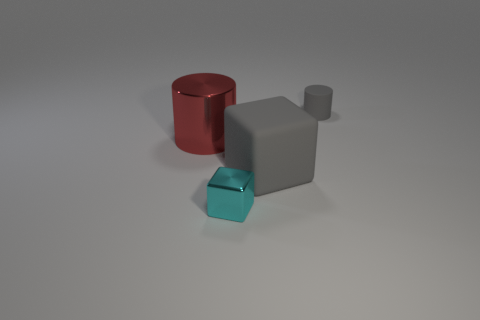Is the material of the small thing that is to the right of the small cyan metal block the same as the big gray cube?
Your answer should be very brief. Yes. How many objects are small cylinders or metallic things in front of the red shiny cylinder?
Keep it short and to the point. 2. What size is the red thing that is the same shape as the tiny gray matte thing?
Keep it short and to the point. Large. There is a large shiny thing; are there any cylinders on the right side of it?
Offer a terse response. Yes. Does the thing that is to the right of the big gray thing have the same color as the matte object that is in front of the tiny gray rubber object?
Give a very brief answer. Yes. Are there any small shiny things that have the same shape as the large gray matte object?
Your response must be concise. Yes. How many other things are the same color as the metal cylinder?
Your answer should be very brief. 0. There is a small object that is in front of the rubber thing that is behind the gray object in front of the big red shiny cylinder; what is its color?
Make the answer very short. Cyan. Is the number of cyan objects that are behind the red shiny object the same as the number of small purple metallic things?
Make the answer very short. Yes. There is a thing in front of the matte cube; is its size the same as the tiny gray rubber cylinder?
Your answer should be very brief. Yes. 